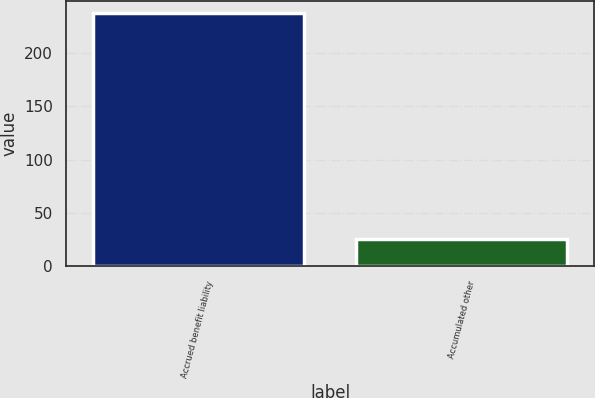Convert chart to OTSL. <chart><loc_0><loc_0><loc_500><loc_500><bar_chart><fcel>Accrued benefit liability<fcel>Accumulated other<nl><fcel>237<fcel>26<nl></chart> 